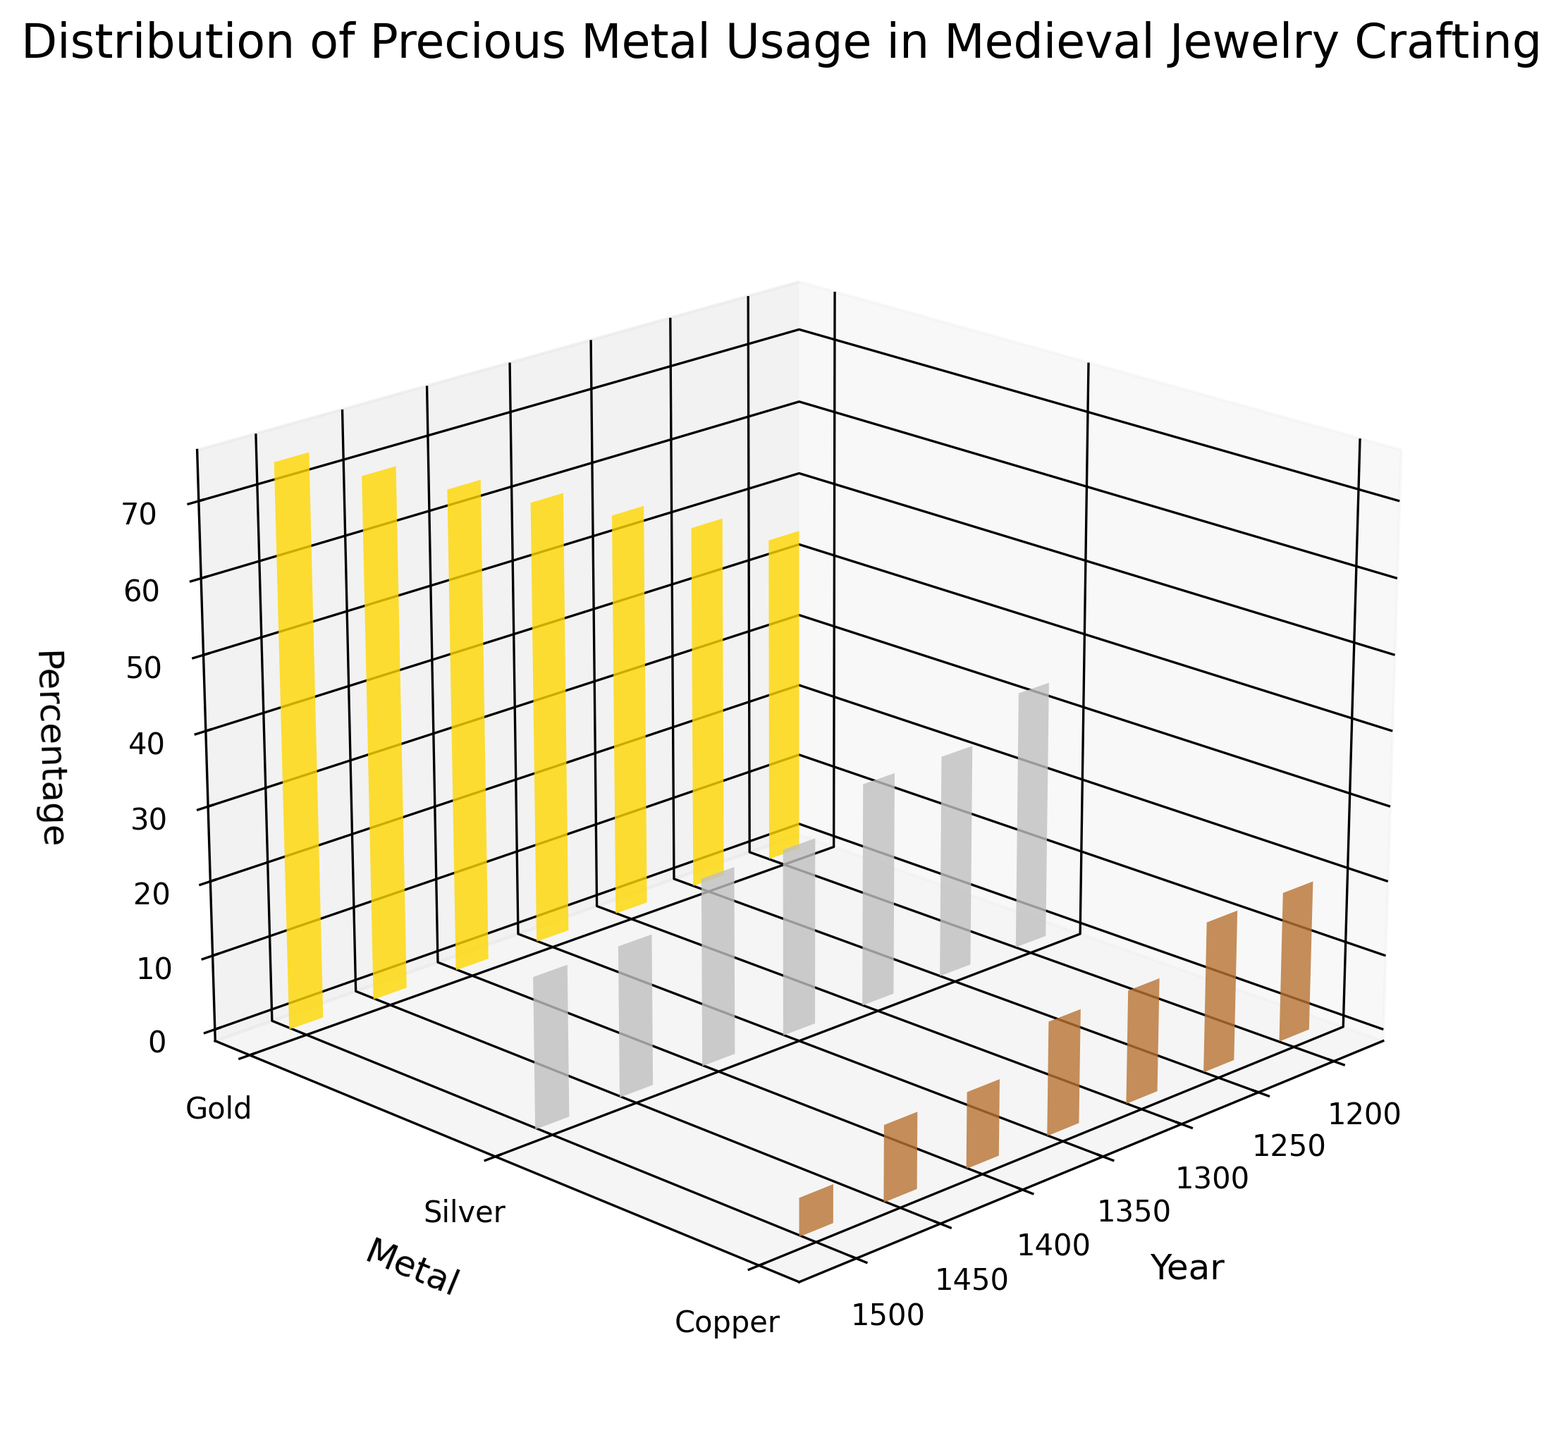What is the title of the figure? The title is displayed at the top of the figure, giving a clear indication of what the plot is about, which is a standard element in a well-labeled plot.
Answer: Distribution of Precious Metal Usage in Medieval Jewelry Crafting What does the x-axis represent? The x-axis labels, typically displayed at the bottom of the figure and indicated in the axis label, represent the specific measurements plotted along this axis.
Answer: Year Which metal shows the highest percentage in the year 1300? By examining the height of the bars at the 1300 mark along the x-axis for each metal's respective color, we can determine the tallest bar. Gold is highest at 55%.
Answer: Gold From 1200 to 1500, how did the usage of gold change? To determine this, we identify the bar heights for gold at each year from 1200 to 1500, noting the increasing values.
Answer: It increased from 45% to 75% What are the colors representing gold, silver, and copper in the plot? The figure uses different colors to represent each metal, which can easily be spotted in the bars. Gold is yellow, silver is gray, and copper is brownish-red.
Answer: Yellow, Gray, Brownish-red Which year features the lowest percentage of copper usage? By comparing the bar heights for copper (brownish-red) across all years, the shortest bar in the year 1500 represents the lowest value at 5%.
Answer: 1500 What's the trend of silver from 1200 to 1500? Observing the heights of the silver (gray) bars over the years, we can trace the trend line. Silver usage decreases overall from 35% to 20%.
Answer: Decreasing Compare the percentage of silver and copper in 1350. Locate the bars for silver and copper at the year 1350 and compare their heights: silver is at 25% and copper is at 15%.
Answer: Silver is greater than copper What is the average percentage of gold usage across all years? The percentages for gold across the years are 45, 50, 55, 60, 65, 70, 75. Summing these and dividing by 7 gives the average: (45+50+55+60+65+70+75)/7 = 60%.
Answer: 60% In which year were the gold and silver percentages equal? From the figure, identify if any year column shows gold and silver bars at the same height. No such year exists where gold and silver are equal.
Answer: None 